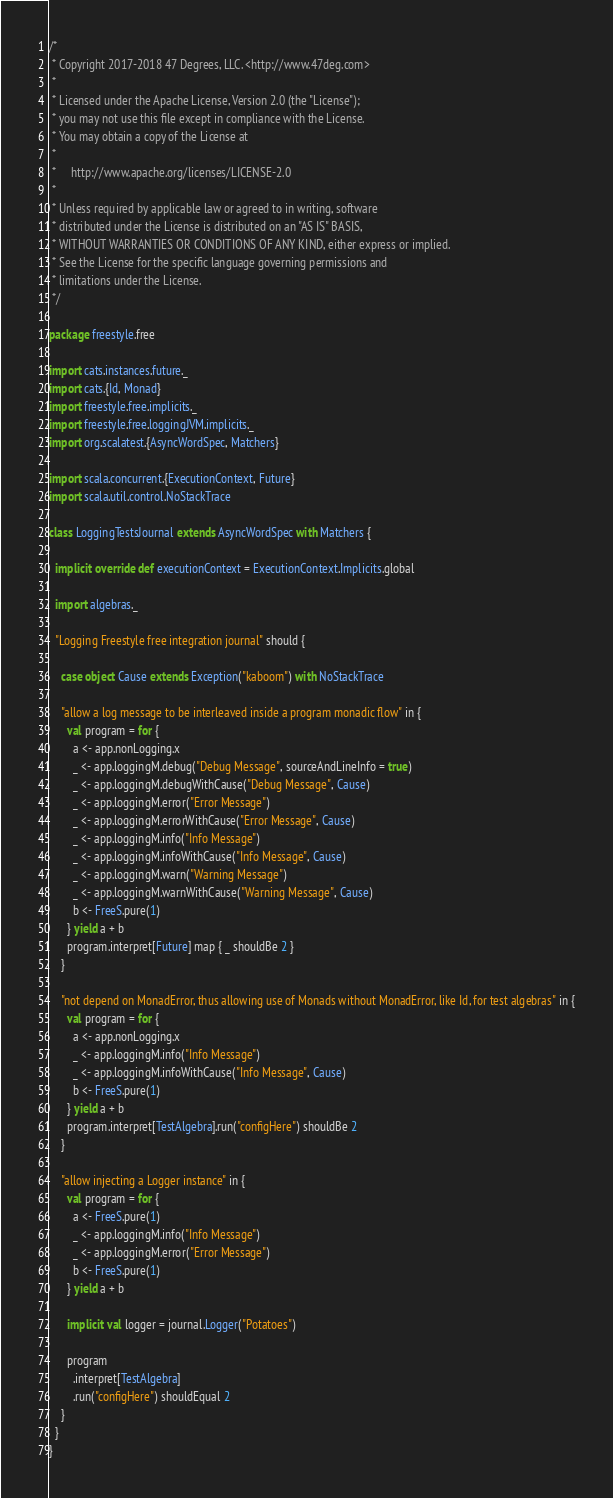<code> <loc_0><loc_0><loc_500><loc_500><_Scala_>/*
 * Copyright 2017-2018 47 Degrees, LLC. <http://www.47deg.com>
 *
 * Licensed under the Apache License, Version 2.0 (the "License");
 * you may not use this file except in compliance with the License.
 * You may obtain a copy of the License at
 *
 *     http://www.apache.org/licenses/LICENSE-2.0
 *
 * Unless required by applicable law or agreed to in writing, software
 * distributed under the License is distributed on an "AS IS" BASIS,
 * WITHOUT WARRANTIES OR CONDITIONS OF ANY KIND, either express or implied.
 * See the License for the specific language governing permissions and
 * limitations under the License.
 */

package freestyle.free

import cats.instances.future._
import cats.{Id, Monad}
import freestyle.free.implicits._
import freestyle.free.loggingJVM.implicits._
import org.scalatest.{AsyncWordSpec, Matchers}

import scala.concurrent.{ExecutionContext, Future}
import scala.util.control.NoStackTrace

class LoggingTestsJournal extends AsyncWordSpec with Matchers {

  implicit override def executionContext = ExecutionContext.Implicits.global

  import algebras._

  "Logging Freestyle free integration journal" should {

    case object Cause extends Exception("kaboom") with NoStackTrace

    "allow a log message to be interleaved inside a program monadic flow" in {
      val program = for {
        a <- app.nonLogging.x
        _ <- app.loggingM.debug("Debug Message", sourceAndLineInfo = true)
        _ <- app.loggingM.debugWithCause("Debug Message", Cause)
        _ <- app.loggingM.error("Error Message")
        _ <- app.loggingM.errorWithCause("Error Message", Cause)
        _ <- app.loggingM.info("Info Message")
        _ <- app.loggingM.infoWithCause("Info Message", Cause)
        _ <- app.loggingM.warn("Warning Message")
        _ <- app.loggingM.warnWithCause("Warning Message", Cause)
        b <- FreeS.pure(1)
      } yield a + b
      program.interpret[Future] map { _ shouldBe 2 }
    }

    "not depend on MonadError, thus allowing use of Monads without MonadError, like Id, for test algebras" in {
      val program = for {
        a <- app.nonLogging.x
        _ <- app.loggingM.info("Info Message")
        _ <- app.loggingM.infoWithCause("Info Message", Cause)
        b <- FreeS.pure(1)
      } yield a + b
      program.interpret[TestAlgebra].run("configHere") shouldBe 2
    }

    "allow injecting a Logger instance" in {
      val program = for {
        a <- FreeS.pure(1)
        _ <- app.loggingM.info("Info Message")
        _ <- app.loggingM.error("Error Message")
        b <- FreeS.pure(1)
      } yield a + b

      implicit val logger = journal.Logger("Potatoes")

      program
        .interpret[TestAlgebra]
        .run("configHere") shouldEqual 2
    }
  }
}
</code> 